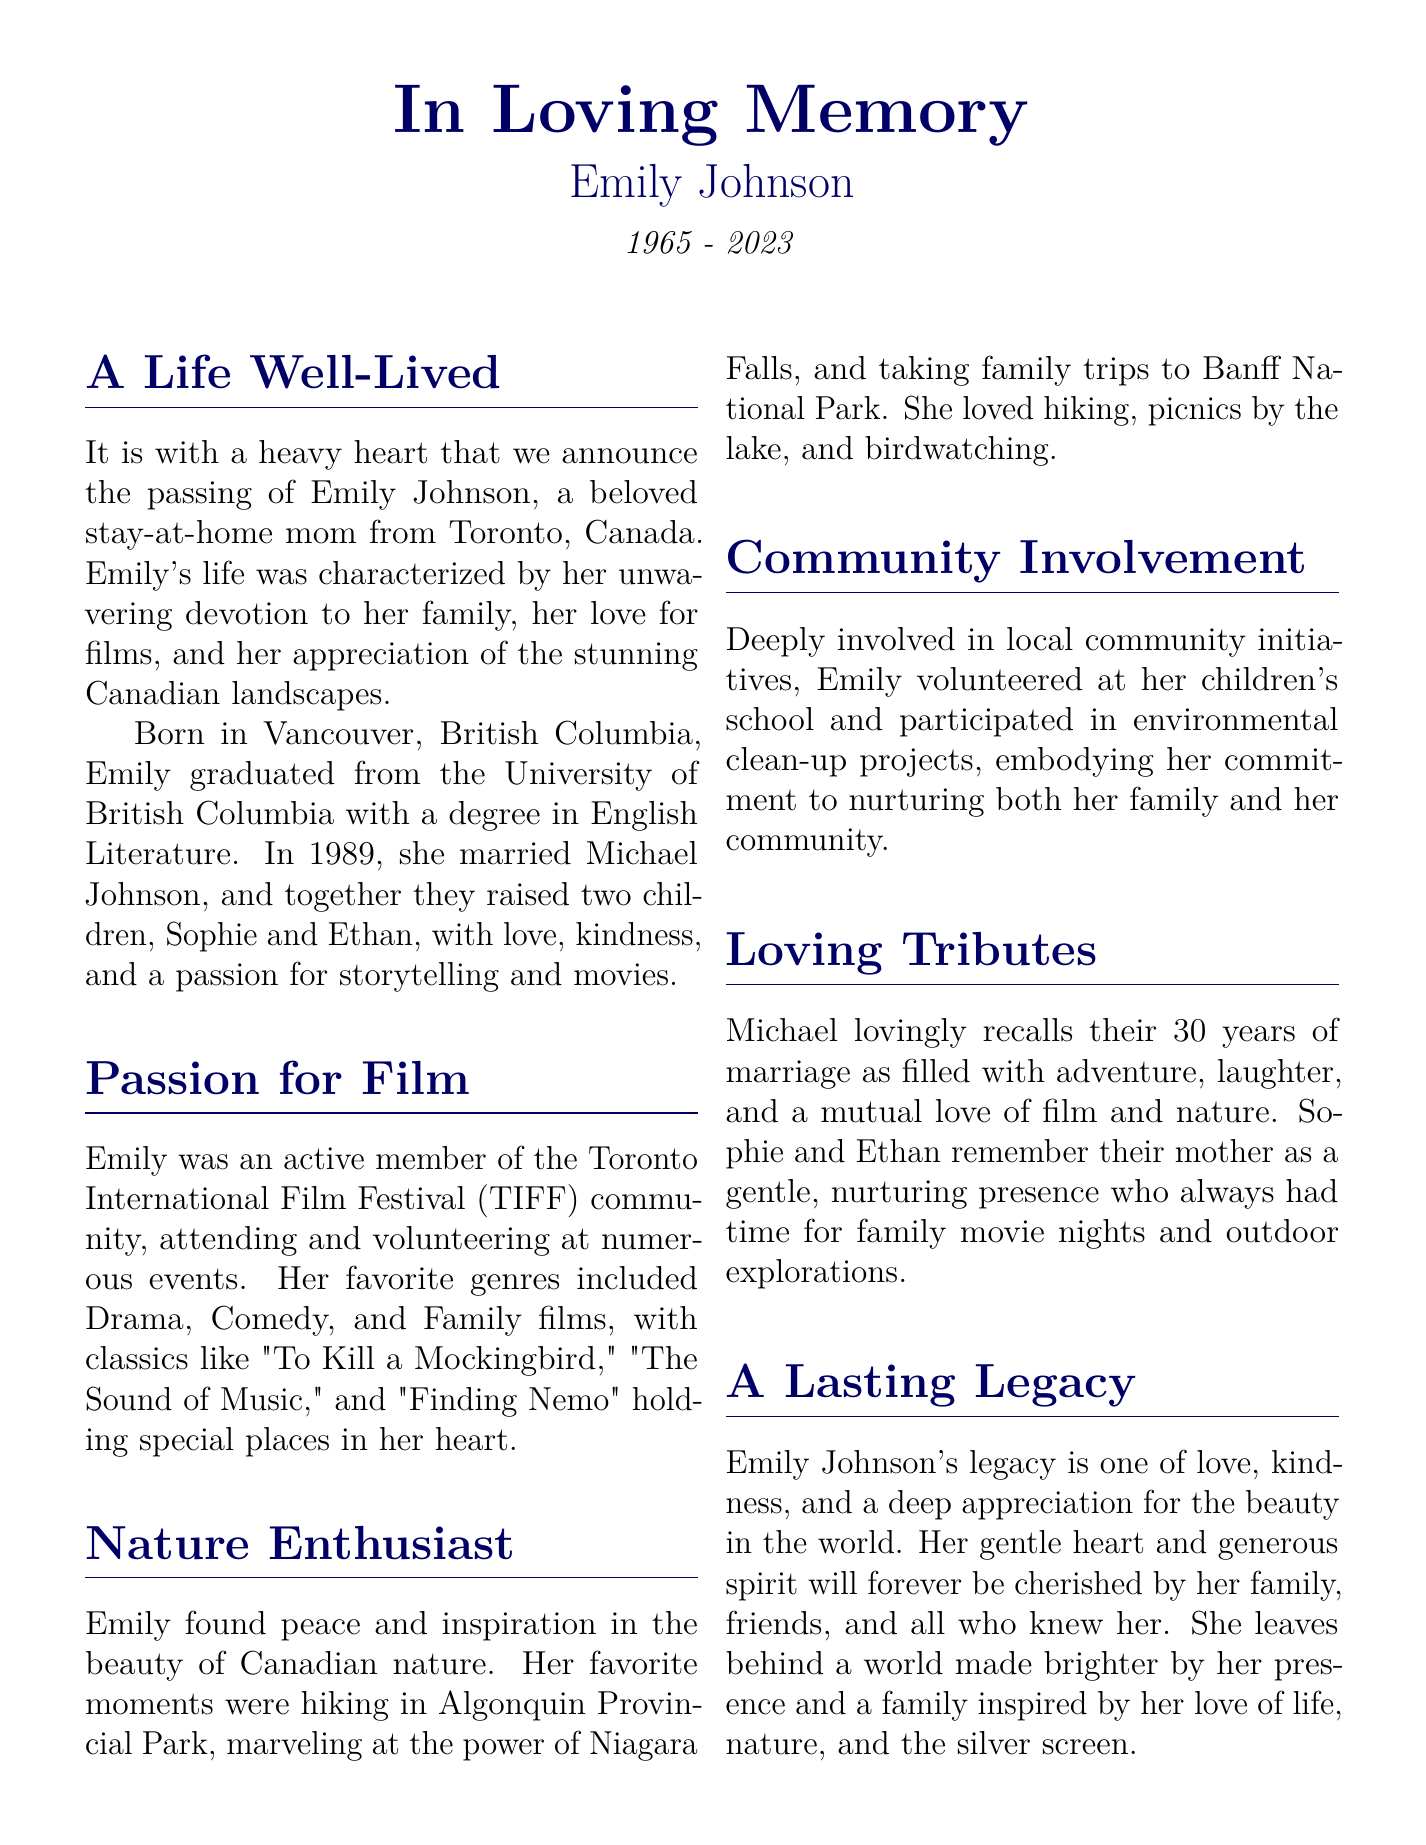What is the full name of the person being remembered? The document provides the full name as Emily Johnson.
Answer: Emily Johnson In what year was Emily born? The document states her birth year as 1965.
Answer: 1965 What year did Emily pass away? The document mentions the year of her passing as 2023.
Answer: 2023 Who are Emily's children? The document lists her children as Sophie and Ethan.
Answer: Sophie and Ethan Which film festival was Emily involved with? The document states she was part of the Toronto International Film Festival (TIFF).
Answer: Toronto International Film Festival (TIFF) What was Emily's favorite outdoor activity? The document mentions that she loved hiking as one of her favorite activities.
Answer: Hiking Which park did Emily enjoy hiking in? The document specifies Algonquin Provincial Park as one of her favorite hiking spots.
Answer: Algonquin Provincial Park How many years were Emily and Michael married? The document indicates they were married for 30 years.
Answer: 30 years What qualities are highlighted in Emily's legacy? The document mentions love, kindness, and appreciation for beauty as her legacy qualities.
Answer: Love, kindness, appreciation for beauty 